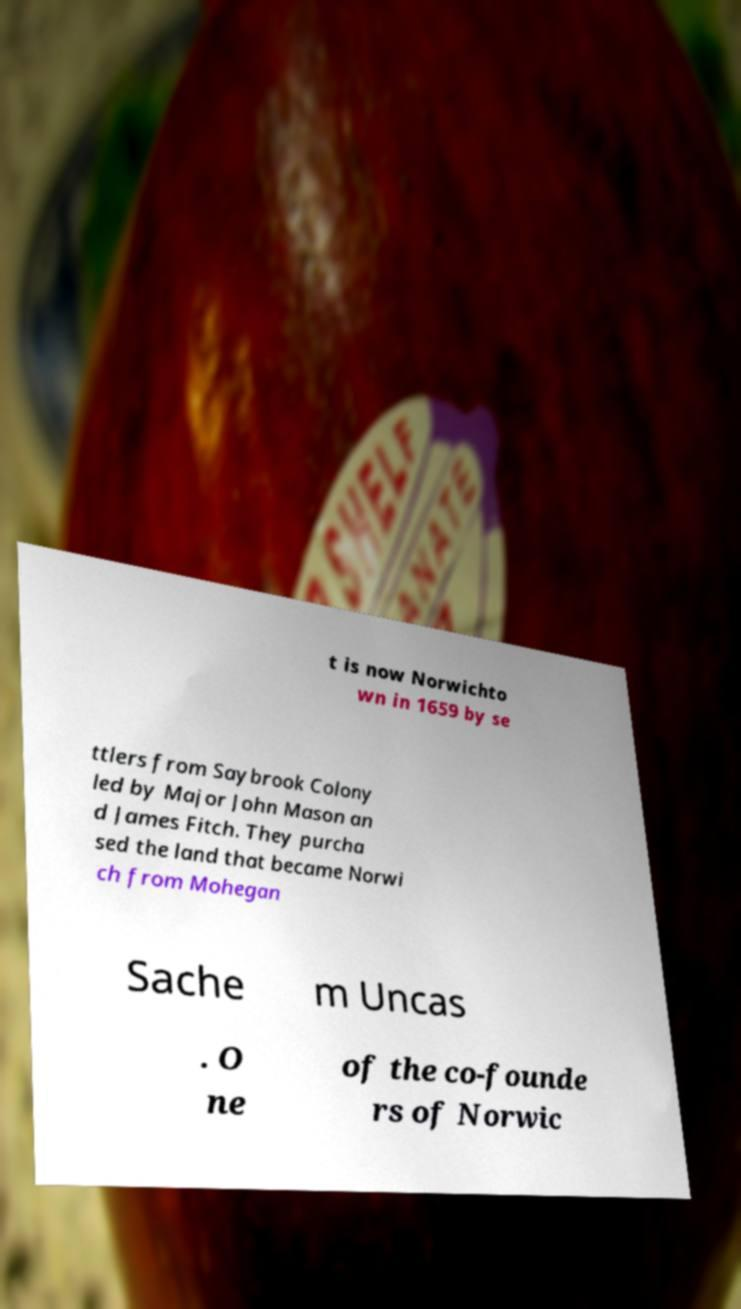I need the written content from this picture converted into text. Can you do that? t is now Norwichto wn in 1659 by se ttlers from Saybrook Colony led by Major John Mason an d James Fitch. They purcha sed the land that became Norwi ch from Mohegan Sache m Uncas . O ne of the co-founde rs of Norwic 